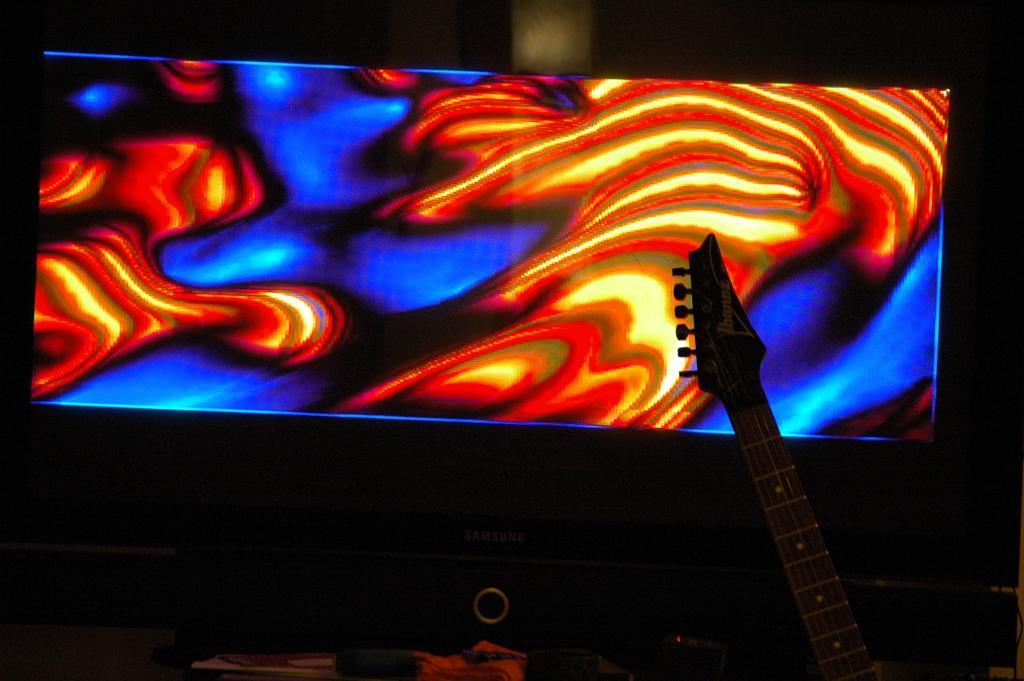Describe this image in one or two sentences. In this image i can see a screen of the monitor and there is a art on the screen with red and blue color and right corner i can see a stand of musical instrument 